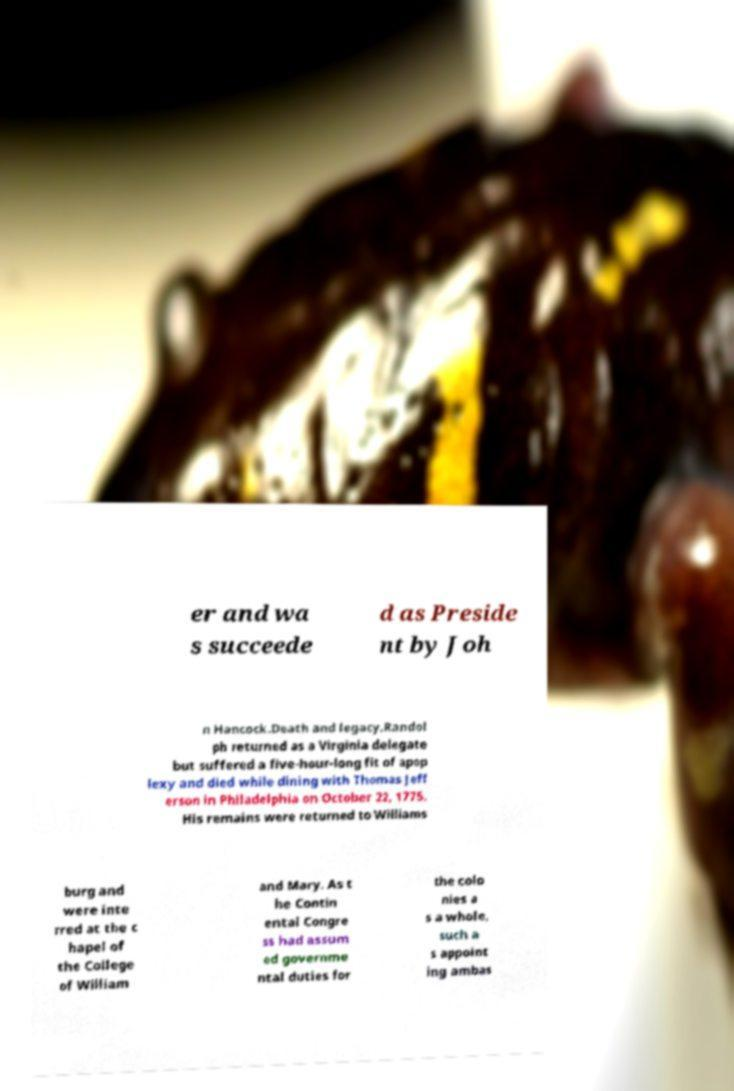There's text embedded in this image that I need extracted. Can you transcribe it verbatim? er and wa s succeede d as Preside nt by Joh n Hancock.Death and legacy.Randol ph returned as a Virginia delegate but suffered a five-hour-long fit of apop lexy and died while dining with Thomas Jeff erson in Philadelphia on October 22, 1775. His remains were returned to Williams burg and were inte rred at the c hapel of the College of William and Mary. As t he Contin ental Congre ss had assum ed governme ntal duties for the colo nies a s a whole, such a s appoint ing ambas 